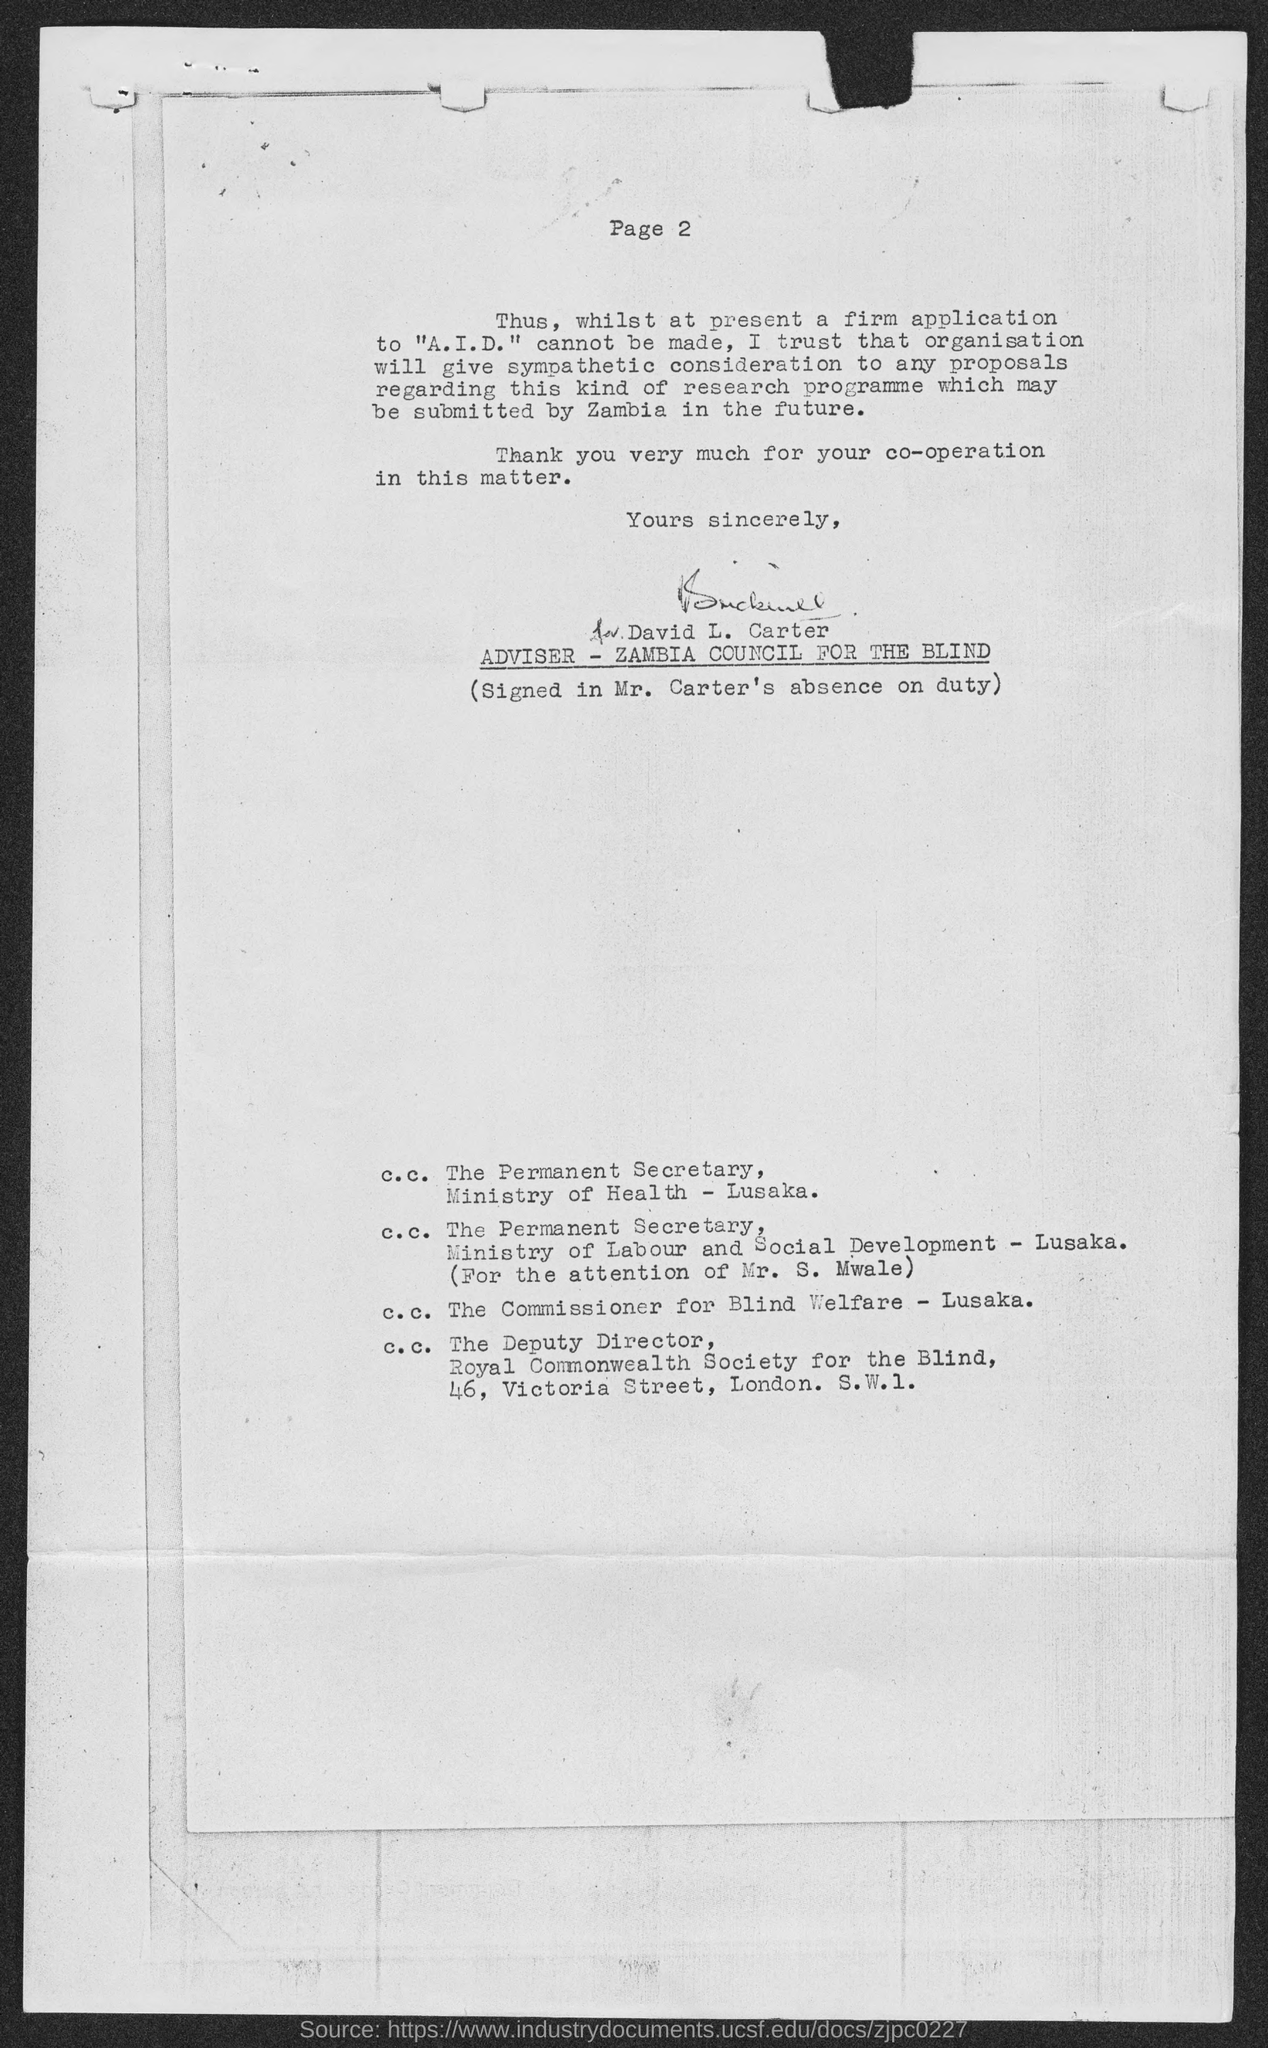What is the page no mentioned in this document?
Your response must be concise. Page 2. Who is the Adviser - Zambia Council for the Blind?
Your answer should be very brief. David L. Carter. 